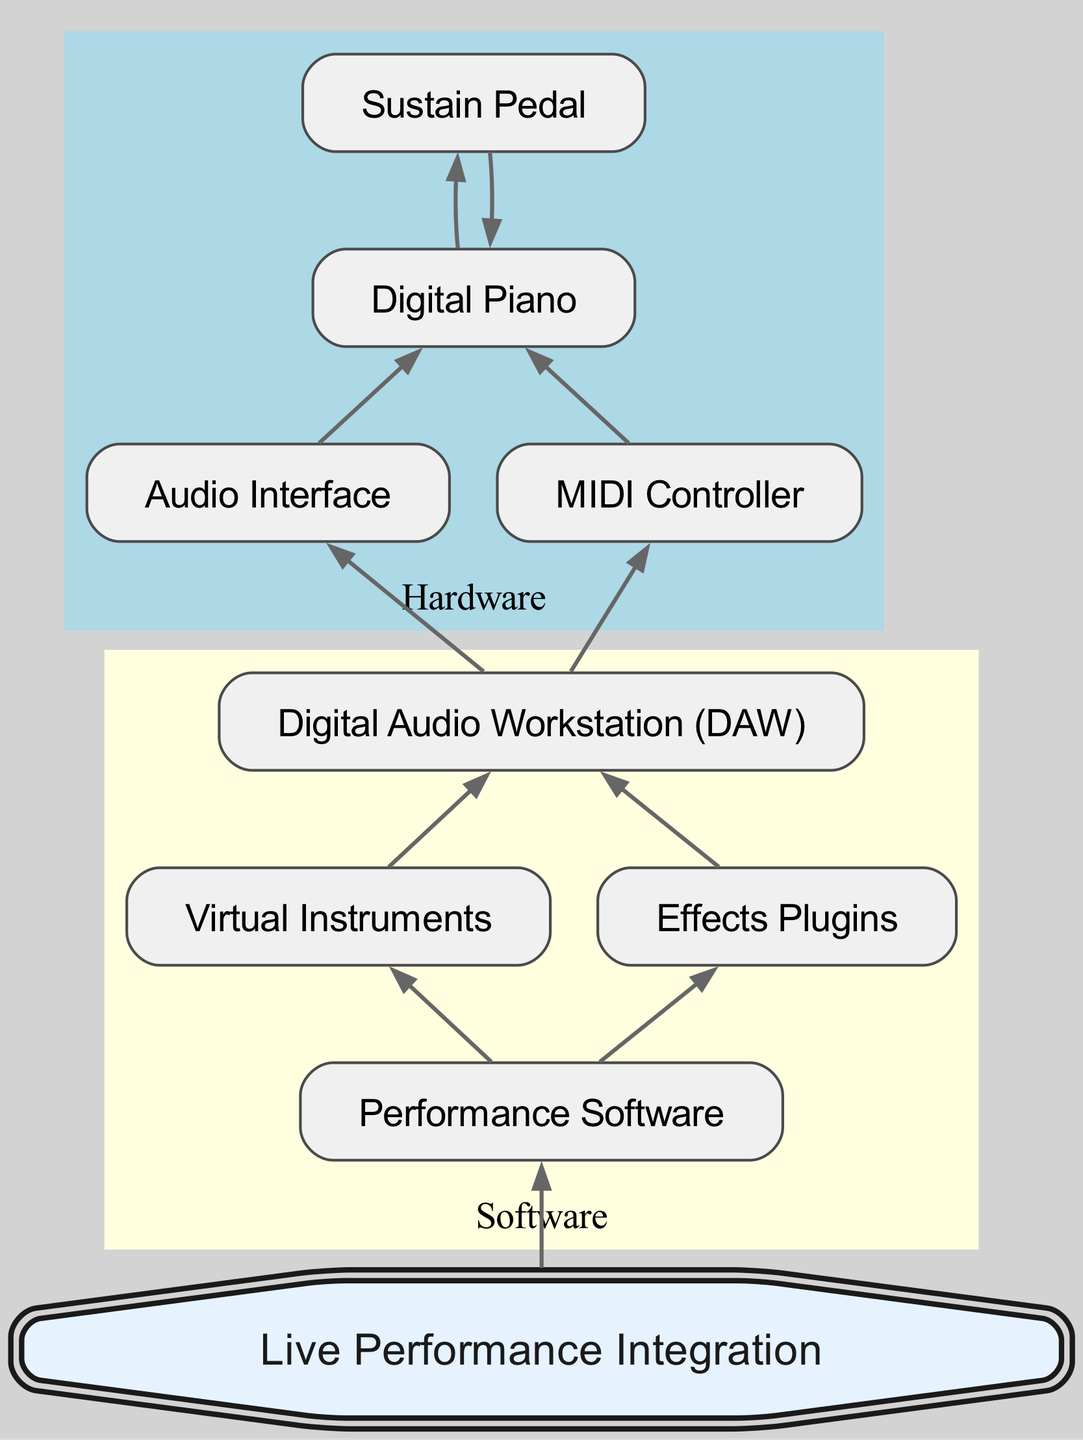What is the top-level component in the setup? The top-level component, representing the foundational element in this digital piano setup, is the digital piano, which encompasses various hardware and software integrations.
Answer: Digital Piano How many hardware components are in the diagram? The diagram illustrates four hardware components: digital piano, audio interface, MIDI controller, and sustain pedal.
Answer: 4 What is the relationship between the digital piano and the sustain pedal? In the diagram, the digital piano relies on the sustain pedal as a direct component, indicating a parent-child relationship where the pedal is an essential accessory for the piano.
Answer: Sustain Pedal Which software components are connected to the Digital Audio Workstation? The Digital Audio Workstation (DAW) is connected to two software components: virtual instruments and effects plugins, demonstrating its role in music production.
Answer: Virtual Instruments, Effects Plugins What is the final output node in this flow chart? The flow chart culminates in the node for live performance integration, indicating that this is the primary outcome of the entire setup process.
Answer: Live Performance Integration Which component serves as a mediator for audio processing? The audio interface acts as a mediator, enabling the digital piano to communicate with the Digital Audio Workstation for audio processing.
Answer: Audio Interface How many edges connect the DAW to other components? There are three outgoing edges from the DAW, connecting it to the virtual instruments, effects plugins, and eventually, the performance software.
Answer: 3 What is the role of performance software in the diagram? Performance software is highlighted as an intermediary that combines virtual instruments and effects plugins to facilitate live performance integration, showcasing its function in the setup.
Answer: Performance Software Which node has the most children? The Digital Audio Workstation (DAW) has the most children, connecting to virtual instruments and effects plugins, which further lead to performance software.
Answer: DAW 